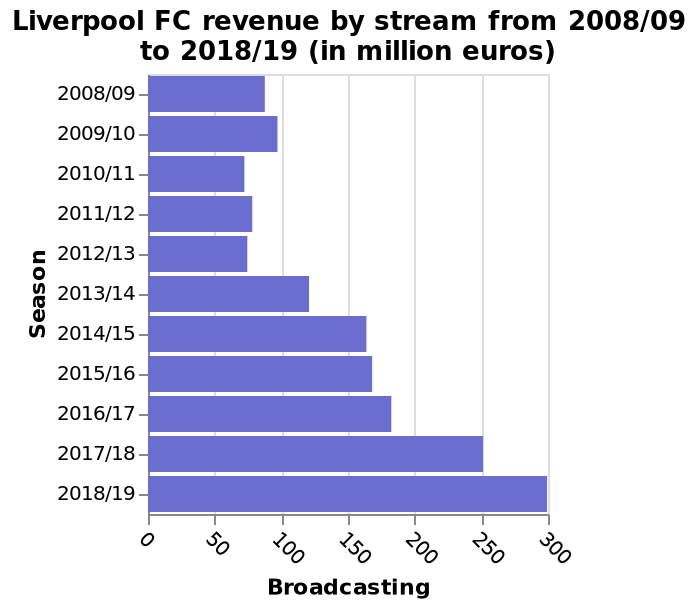<image>
What is measured on the y-axis of the bar chart? On the y-axis of the bar chart, the season is measured. During which years did Liverpool's revenue growth remain stagnant? Liverpool's revenue growth was relatively stagnant between 2010-2012. How is the x-axis scale measured for the Broadcasting? The x-axis scale for the Broadcasting is measured using a linear scale ranging from 0 to 300. 